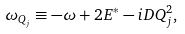<formula> <loc_0><loc_0><loc_500><loc_500>\omega _ { Q _ { j } } \equiv - \omega + 2 E ^ { * } - i D Q ^ { 2 } _ { j } ,</formula> 